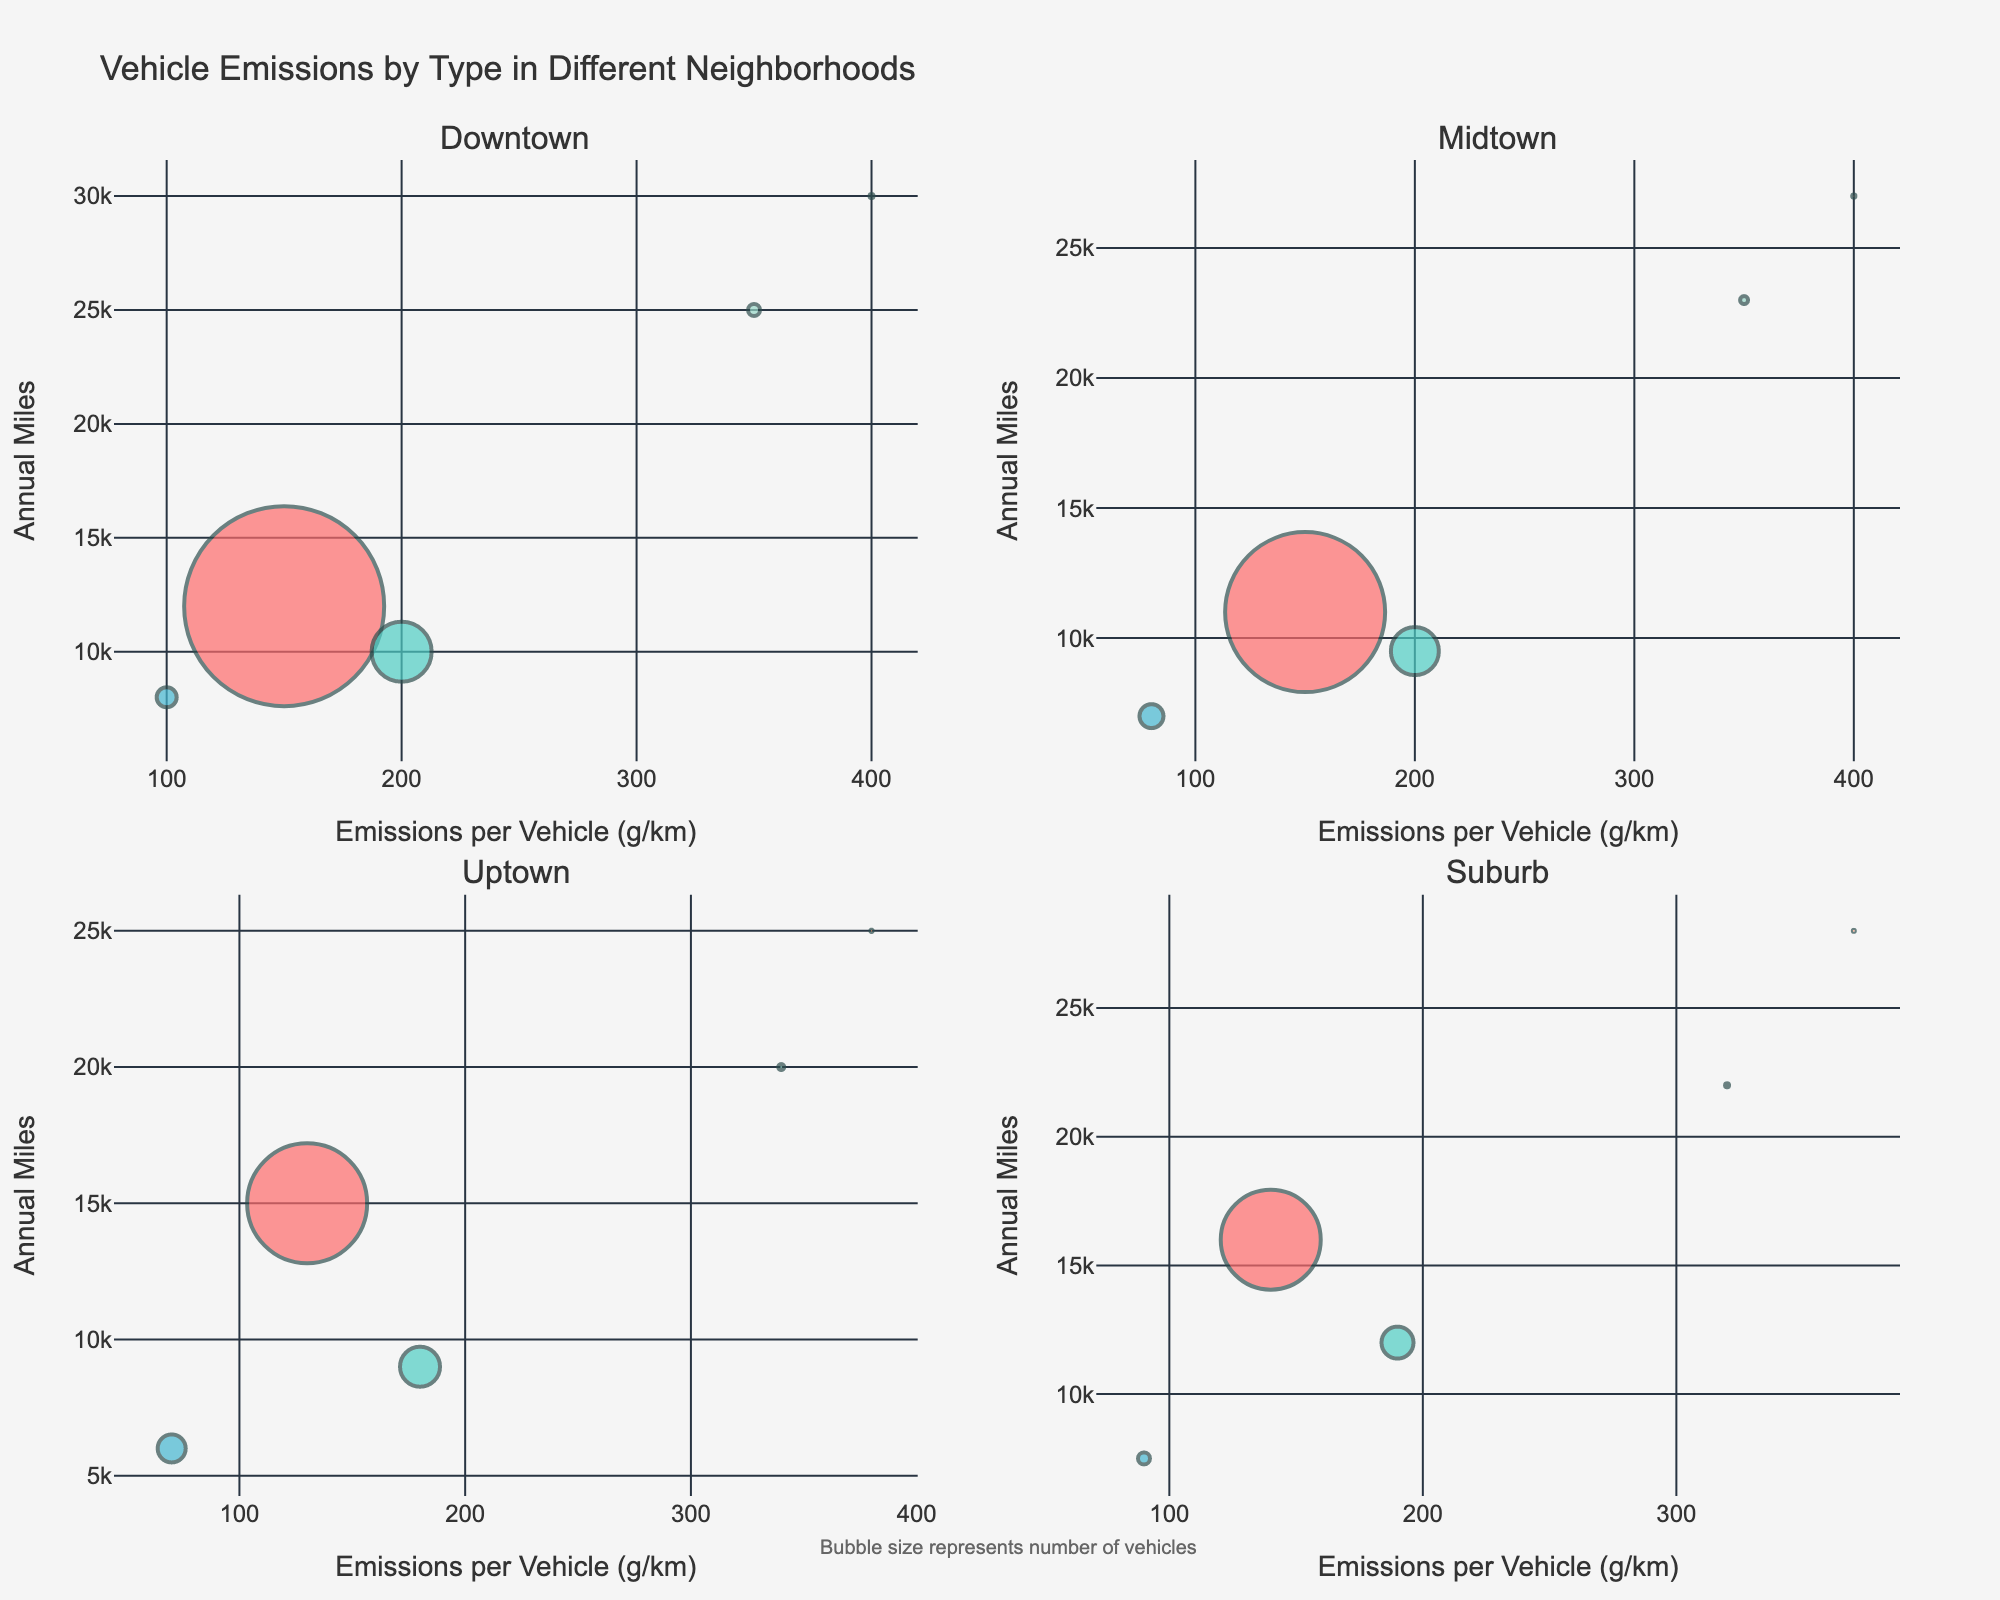How many neighborhoods are represented in the figure? The figure has subplots for each neighborhood, showing vehicle types and their emissions. There are 4 subplot titles indicating 4 neighborhoods: Downtown, Midtown, Uptown, and Suburb
Answer: 4 Which vehicle type in Downtown has the highest average annual miles? In the Downtown subplot, the y-axis represents annual miles, and the highest point on this axis corresponds to the Bus, with a value of 30,000 miles.
Answer: Bus Comparing Passenger Cars in Downtown and Midtown, which neighborhood has more vehicles? Both Downtown and Midtown have Passenger Car data points. The bubble size represents the number of vehicles, and the bubble for Downtown is larger than the one for Midtown, indicating more vehicles.
Answer: Downtown What is the average emissions per vehicle for Light Trucks in Uptown? In the Uptown subplot, locate the Light Truck data point. The x-axis represents emissions per vehicle, and the corresponding value is 180 g/km.
Answer: 180 g/km Which vehicle type in Suburb has the least average annual miles? In the Suburb subplot, find the lowest data point on the y-axis representing annual miles. The Motorcycle has the lowest value at 7,500 miles.
Answer: Motorcycle Between Heavy Trucks in Downtown and Suburb, which one has higher emissions per vehicle? Compare the Heavy Truck data points in the Downtown and Suburb subplots. On the x-axis, Downtown shows 350 g/km, and Suburb shows 320 g/km.
Answer: Downtown How are the sizes of the bubbles determined in the subplots? According to the figure explanation, bubble sizes are determined by the number of vehicles in each category. Larger bubbles indicate more vehicles.
Answer: Number of vehicles Which vehicle type in Midtown emits the least amount of emissions per vehicle? In the Midtown subplot, the smallest value on the x-axis represents the Motorcycle, with emissions of 80 g/km.
Answer: Motorcycle In which neighborhood do Buses have the second highest average annual miles? Analyze the Bus data points across the subplots. Downtown (30,000 miles) has the highest, followed by Suburb (28,000 miles).
Answer: Suburb What is the relationship between average annual miles and average emissions per vehicle for Heavy Trucks across all neighborhoods? In each subplot, locate the Heavy Truck data points. Across neighborhoods, you observe that as annual miles increase or decrease, the emissions remain around 320-350 g/km, indicating not much variation with miles.
Answer: Stable emissions 